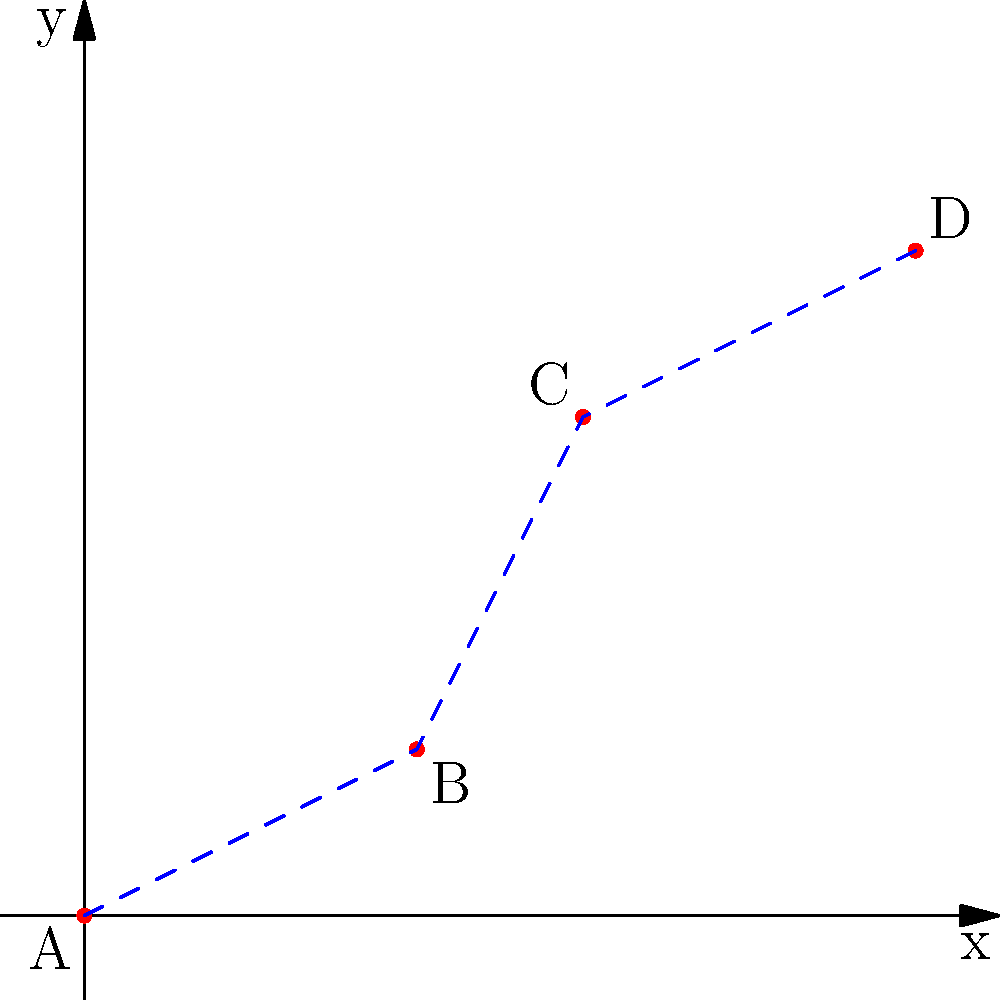In an ancient ritual procession, participants move along a specific route on a sacred grid. The route is represented by points A(0,0), B(2,1), C(3,3), and D(5,4) on a 2D coordinate system. What is the total distance traveled during the procession, rounded to the nearest whole number? To find the total distance traveled, we need to calculate the distances between consecutive points and sum them up. We'll use the distance formula for each segment:

$d = \sqrt{(x_2-x_1)^2 + (y_2-y_1)^2}$

1. Distance from A to B:
   $d_{AB} = \sqrt{(2-0)^2 + (1-0)^2} = \sqrt{4 + 1} = \sqrt{5} \approx 2.24$

2. Distance from B to C:
   $d_{BC} = \sqrt{(3-2)^2 + (3-1)^2} = \sqrt{1 + 4} = \sqrt{5} \approx 2.24$

3. Distance from C to D:
   $d_{CD} = \sqrt{(5-3)^2 + (4-3)^2} = \sqrt{4 + 1} = \sqrt{5} \approx 2.24$

4. Total distance:
   $d_{total} = d_{AB} + d_{BC} + d_{CD} \approx 2.24 + 2.24 + 2.24 = 6.72$

5. Rounding to the nearest whole number:
   $6.72 \approx 7$

Therefore, the total distance traveled during the procession, rounded to the nearest whole number, is 7 units.
Answer: 7 